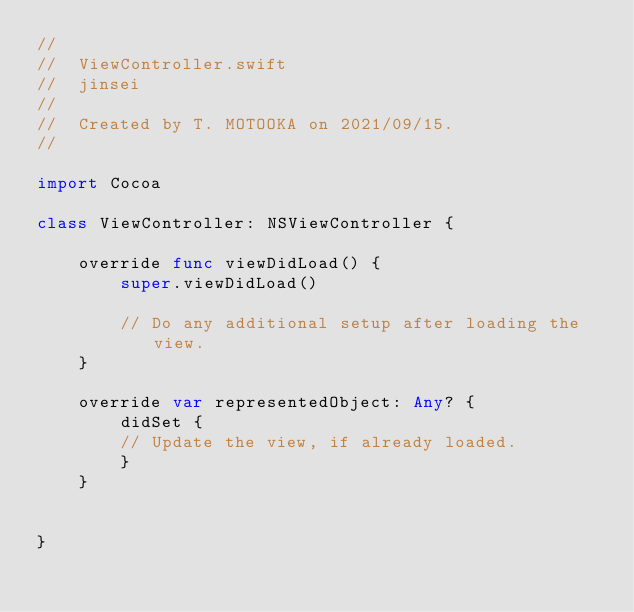<code> <loc_0><loc_0><loc_500><loc_500><_Swift_>//
//  ViewController.swift
//  jinsei
//
//  Created by T. MOTOOKA on 2021/09/15.
//

import Cocoa

class ViewController: NSViewController {

	override func viewDidLoad() {
		super.viewDidLoad()

		// Do any additional setup after loading the view.
	}

	override var representedObject: Any? {
		didSet {
		// Update the view, if already loaded.
		}
	}


}

</code> 